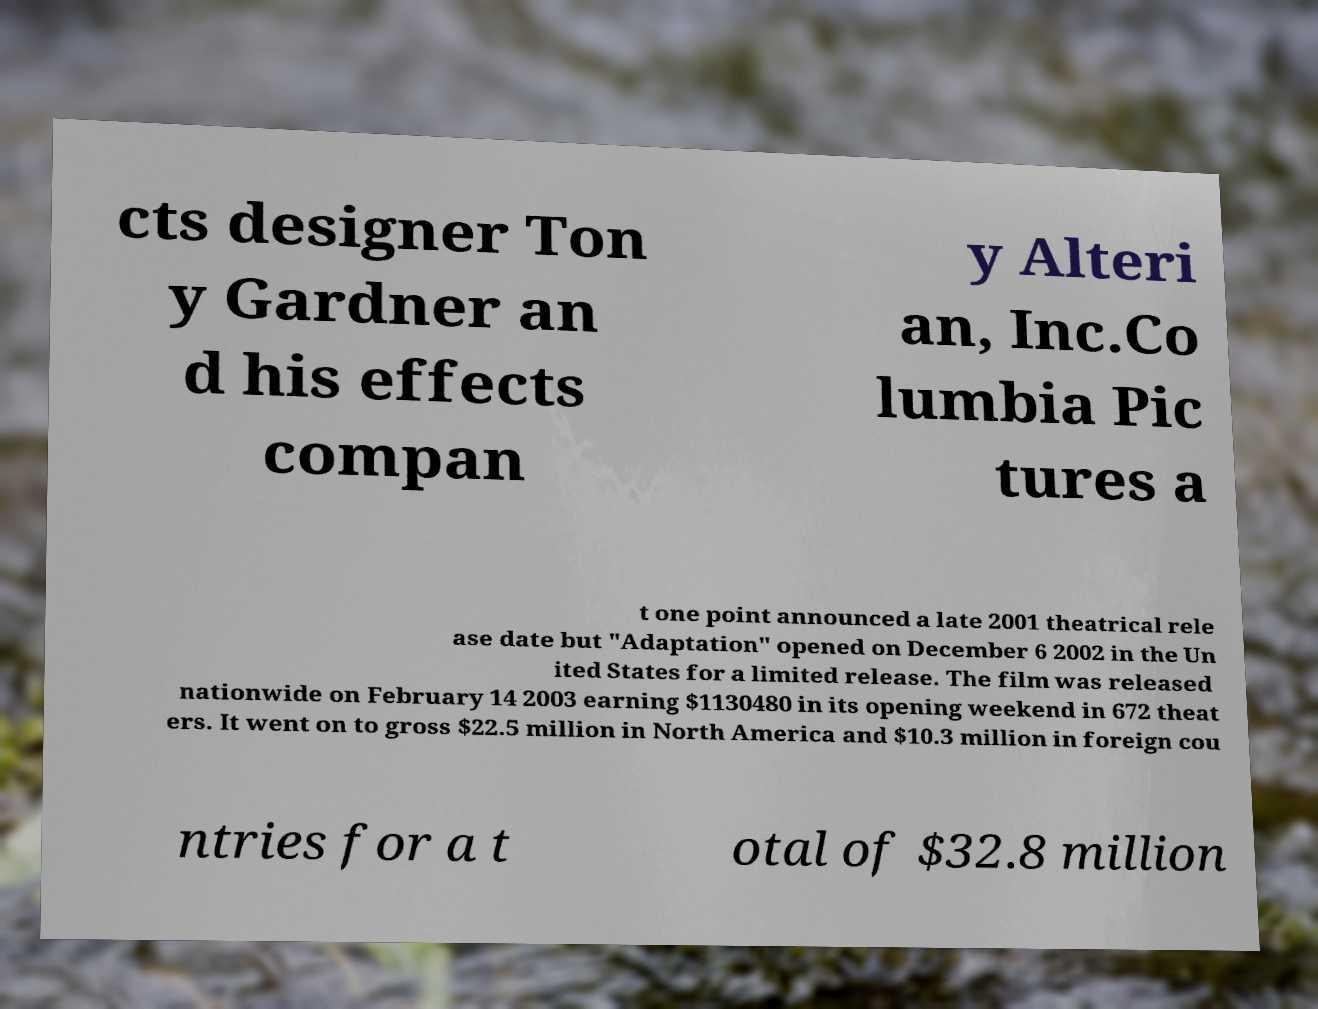What messages or text are displayed in this image? I need them in a readable, typed format. cts designer Ton y Gardner an d his effects compan y Alteri an, Inc.Co lumbia Pic tures a t one point announced a late 2001 theatrical rele ase date but "Adaptation" opened on December 6 2002 in the Un ited States for a limited release. The film was released nationwide on February 14 2003 earning $1130480 in its opening weekend in 672 theat ers. It went on to gross $22.5 million in North America and $10.3 million in foreign cou ntries for a t otal of $32.8 million 